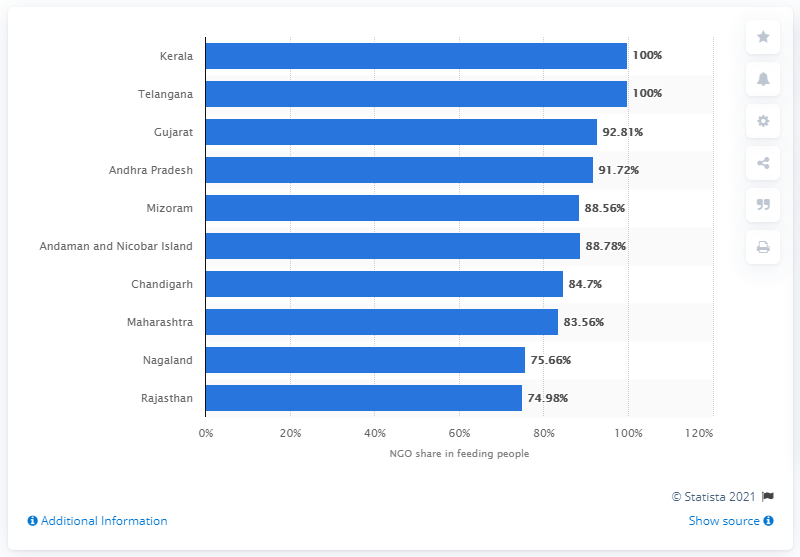Specify some key components in this picture. In Kerala and Telangana, NGOs provided a significant amount of food to needy individuals, with a total of 75.66 ..... 